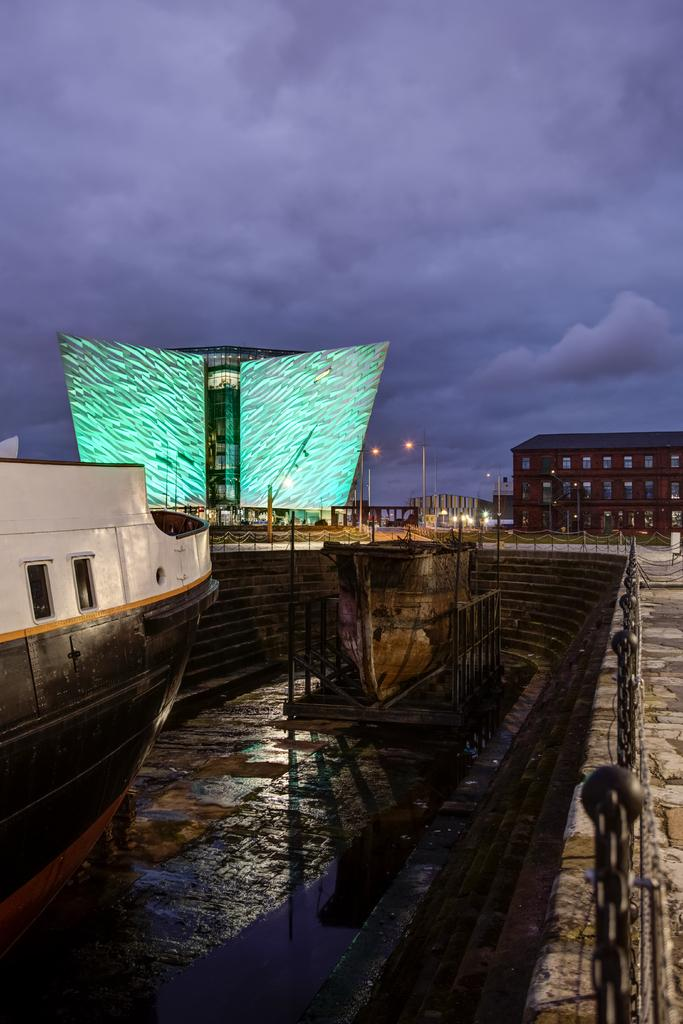What can be seen floating on the surface in the image? There are boats on the surface in the image. What type of structure is present in the image? There is a staircase in the image. What are the poles with chains used for in the image? The poles with chains are used for mooring the boats in the image. What type of man-made structures are visible in the image? There is a group of buildings in the image. What type of vertical structures are present in the image? There are street poles in the image. What is the condition of the sky in the image? The sky is visible in the image and appears cloudy. What type of polish is being applied to the fork in the image? There is no fork present in the image, and therefore no polish is being applied. How does the behavior of the people in the image change throughout the day? The image does not show any people, so their behavior cannot be observed or described. 